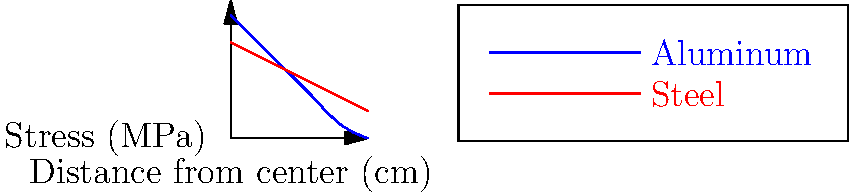The graph above shows the stress distribution on skateboard trucks made of aluminum and steel using finite element analysis. Based on the graph, which material would likely provide better overall performance for a skateboard truck, and why? To answer this question, we need to analyze the stress distribution patterns for both materials:

1. Stress concentration:
   - Aluminum: Higher stress near the center (9 MPa at 0 cm)
   - Steel: Lower stress near the center (7 MPa at 0 cm)

2. Stress distribution:
   - Aluminum: Steeper decline in stress from center to edge
   - Steel: More gradual decline in stress from center to edge

3. Stress at the edges:
   - Aluminum: Lower stress at the edges (approaching 0 MPa at 10 cm)
   - Steel: Higher stress at the edges (about 2 MPa at 10 cm)

4. Overall stress pattern:
   - Aluminum: More uneven distribution
   - Steel: More even distribution

5. Implications for performance:
   - Aluminum:
     a. Lighter weight (advantage for tricks and maneuverability)
     b. More flexible (can absorb impacts better)
     c. Higher stress concentration (potential weakness)
   - Steel:
     a. Heavier (disadvantage for tricks, but provides stability)
     b. More even stress distribution (better durability)
     c. Lower overall stress (longer lifespan)

6. Conclusion:
   Steel would likely provide better overall performance for a skateboard truck due to its more even stress distribution and lower overall stress levels. This translates to better durability and a longer lifespan, which are crucial for skateboard trucks that undergo repeated stress during use.

However, the choice between aluminum and steel may depend on the skater's specific needs and preferences, such as prioritizing weight savings for technical tricks versus durability for rough terrain or heavy use.
Answer: Steel, due to more even stress distribution and lower overall stress levels, providing better durability and longer lifespan. 